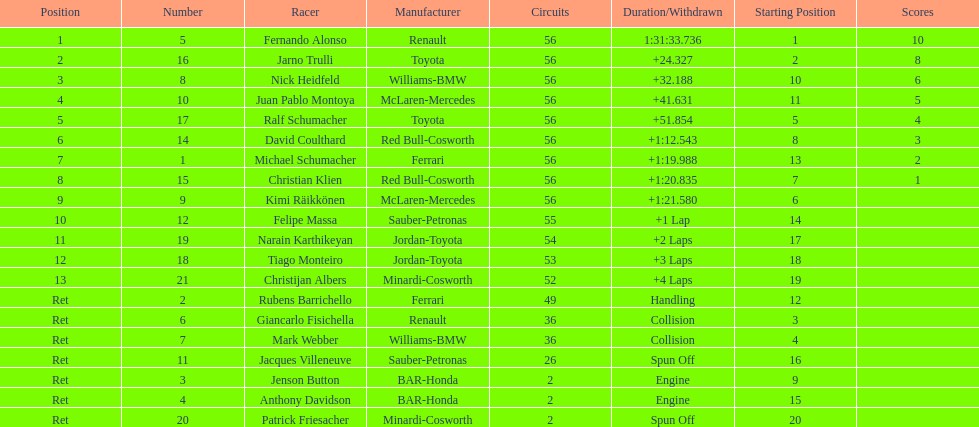What were the total number of laps completed by the 1st position winner? 56. 